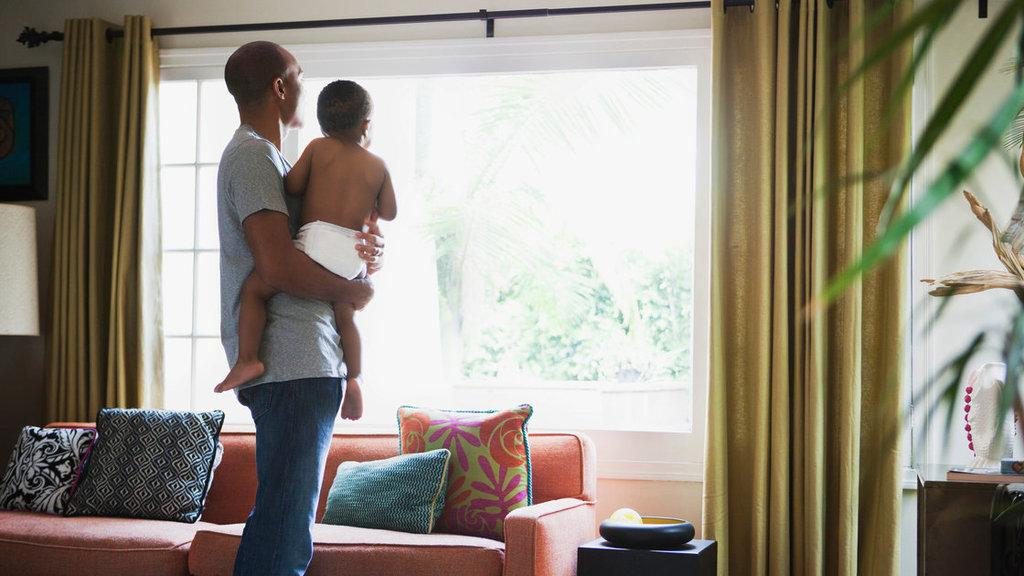What is the man in the image doing? The man is carrying a child in the image. What is in front of the man? There is a window in front of the man. What is associated with the window? There are curtains associated with the window. What is in front of the window? There is a sofa in front of the window. What is on the sofa? There are pillows on the sofa. What type of gold object is the child holding in the image? There is no gold object present in the image, and the child is not holding anything. 